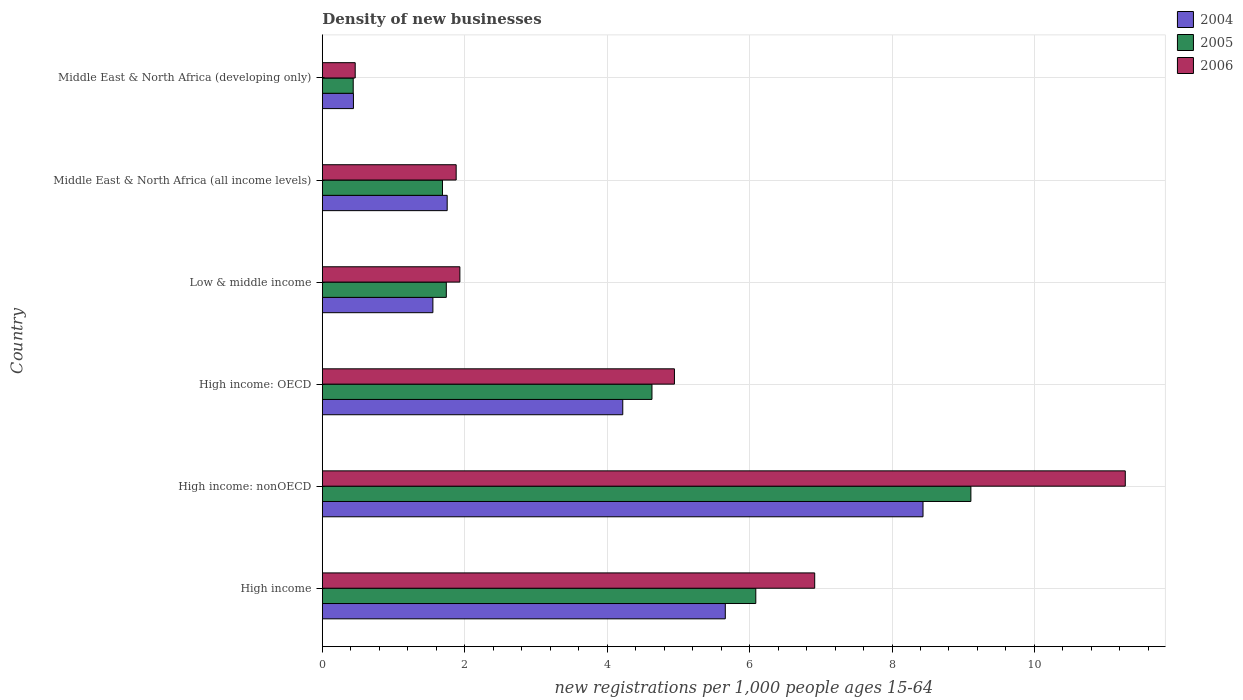How many groups of bars are there?
Provide a succinct answer. 6. Are the number of bars per tick equal to the number of legend labels?
Keep it short and to the point. Yes. What is the label of the 2nd group of bars from the top?
Your answer should be compact. Middle East & North Africa (all income levels). In how many cases, is the number of bars for a given country not equal to the number of legend labels?
Ensure brevity in your answer.  0. What is the number of new registrations in 2006 in High income: OECD?
Your answer should be very brief. 4.94. Across all countries, what is the maximum number of new registrations in 2006?
Offer a terse response. 11.28. Across all countries, what is the minimum number of new registrations in 2004?
Make the answer very short. 0.44. In which country was the number of new registrations in 2004 maximum?
Give a very brief answer. High income: nonOECD. In which country was the number of new registrations in 2006 minimum?
Your answer should be compact. Middle East & North Africa (developing only). What is the total number of new registrations in 2005 in the graph?
Offer a terse response. 23.69. What is the difference between the number of new registrations in 2005 in Low & middle income and that in Middle East & North Africa (all income levels)?
Provide a short and direct response. 0.05. What is the difference between the number of new registrations in 2004 in Middle East & North Africa (developing only) and the number of new registrations in 2005 in High income: nonOECD?
Make the answer very short. -8.67. What is the average number of new registrations in 2005 per country?
Offer a very short reply. 3.95. What is the difference between the number of new registrations in 2006 and number of new registrations in 2004 in High income: OECD?
Provide a short and direct response. 0.73. In how many countries, is the number of new registrations in 2004 greater than 8.4 ?
Give a very brief answer. 1. What is the ratio of the number of new registrations in 2006 in High income: OECD to that in Middle East & North Africa (all income levels)?
Provide a short and direct response. 2.63. Is the number of new registrations in 2005 in High income: OECD less than that in High income: nonOECD?
Your response must be concise. Yes. What is the difference between the highest and the second highest number of new registrations in 2006?
Your response must be concise. 4.36. What is the difference between the highest and the lowest number of new registrations in 2004?
Your answer should be compact. 8. In how many countries, is the number of new registrations in 2006 greater than the average number of new registrations in 2006 taken over all countries?
Offer a terse response. 3. Is the sum of the number of new registrations in 2004 in High income: OECD and Middle East & North Africa (all income levels) greater than the maximum number of new registrations in 2006 across all countries?
Provide a succinct answer. No. What does the 3rd bar from the top in Middle East & North Africa (all income levels) represents?
Make the answer very short. 2004. Is it the case that in every country, the sum of the number of new registrations in 2006 and number of new registrations in 2004 is greater than the number of new registrations in 2005?
Keep it short and to the point. Yes. Are all the bars in the graph horizontal?
Your answer should be compact. Yes. How many countries are there in the graph?
Provide a succinct answer. 6. Are the values on the major ticks of X-axis written in scientific E-notation?
Your response must be concise. No. Does the graph contain any zero values?
Your answer should be compact. No. Does the graph contain grids?
Your response must be concise. Yes. Where does the legend appear in the graph?
Make the answer very short. Top right. How are the legend labels stacked?
Your answer should be very brief. Vertical. What is the title of the graph?
Your response must be concise. Density of new businesses. Does "1962" appear as one of the legend labels in the graph?
Your answer should be compact. No. What is the label or title of the X-axis?
Ensure brevity in your answer.  New registrations per 1,0 people ages 15-64. What is the new registrations per 1,000 people ages 15-64 in 2004 in High income?
Your answer should be very brief. 5.66. What is the new registrations per 1,000 people ages 15-64 in 2005 in High income?
Give a very brief answer. 6.09. What is the new registrations per 1,000 people ages 15-64 in 2006 in High income?
Offer a very short reply. 6.91. What is the new registrations per 1,000 people ages 15-64 in 2004 in High income: nonOECD?
Provide a short and direct response. 8.44. What is the new registrations per 1,000 people ages 15-64 of 2005 in High income: nonOECD?
Make the answer very short. 9.11. What is the new registrations per 1,000 people ages 15-64 in 2006 in High income: nonOECD?
Keep it short and to the point. 11.28. What is the new registrations per 1,000 people ages 15-64 in 2004 in High income: OECD?
Offer a very short reply. 4.22. What is the new registrations per 1,000 people ages 15-64 of 2005 in High income: OECD?
Keep it short and to the point. 4.63. What is the new registrations per 1,000 people ages 15-64 in 2006 in High income: OECD?
Offer a terse response. 4.94. What is the new registrations per 1,000 people ages 15-64 in 2004 in Low & middle income?
Your answer should be very brief. 1.55. What is the new registrations per 1,000 people ages 15-64 in 2005 in Low & middle income?
Make the answer very short. 1.74. What is the new registrations per 1,000 people ages 15-64 of 2006 in Low & middle income?
Your answer should be very brief. 1.93. What is the new registrations per 1,000 people ages 15-64 in 2004 in Middle East & North Africa (all income levels)?
Give a very brief answer. 1.75. What is the new registrations per 1,000 people ages 15-64 of 2005 in Middle East & North Africa (all income levels)?
Give a very brief answer. 1.69. What is the new registrations per 1,000 people ages 15-64 in 2006 in Middle East & North Africa (all income levels)?
Offer a terse response. 1.88. What is the new registrations per 1,000 people ages 15-64 of 2004 in Middle East & North Africa (developing only)?
Give a very brief answer. 0.44. What is the new registrations per 1,000 people ages 15-64 in 2005 in Middle East & North Africa (developing only)?
Make the answer very short. 0.43. What is the new registrations per 1,000 people ages 15-64 in 2006 in Middle East & North Africa (developing only)?
Your answer should be very brief. 0.46. Across all countries, what is the maximum new registrations per 1,000 people ages 15-64 in 2004?
Offer a terse response. 8.44. Across all countries, what is the maximum new registrations per 1,000 people ages 15-64 of 2005?
Provide a succinct answer. 9.11. Across all countries, what is the maximum new registrations per 1,000 people ages 15-64 of 2006?
Your answer should be very brief. 11.28. Across all countries, what is the minimum new registrations per 1,000 people ages 15-64 of 2004?
Offer a terse response. 0.44. Across all countries, what is the minimum new registrations per 1,000 people ages 15-64 in 2005?
Ensure brevity in your answer.  0.43. Across all countries, what is the minimum new registrations per 1,000 people ages 15-64 in 2006?
Offer a terse response. 0.46. What is the total new registrations per 1,000 people ages 15-64 of 2004 in the graph?
Keep it short and to the point. 22.06. What is the total new registrations per 1,000 people ages 15-64 of 2005 in the graph?
Give a very brief answer. 23.69. What is the total new registrations per 1,000 people ages 15-64 of 2006 in the graph?
Make the answer very short. 27.41. What is the difference between the new registrations per 1,000 people ages 15-64 in 2004 in High income and that in High income: nonOECD?
Give a very brief answer. -2.78. What is the difference between the new registrations per 1,000 people ages 15-64 of 2005 in High income and that in High income: nonOECD?
Offer a very short reply. -3.02. What is the difference between the new registrations per 1,000 people ages 15-64 of 2006 in High income and that in High income: nonOECD?
Make the answer very short. -4.36. What is the difference between the new registrations per 1,000 people ages 15-64 in 2004 in High income and that in High income: OECD?
Offer a terse response. 1.44. What is the difference between the new registrations per 1,000 people ages 15-64 of 2005 in High income and that in High income: OECD?
Ensure brevity in your answer.  1.46. What is the difference between the new registrations per 1,000 people ages 15-64 of 2006 in High income and that in High income: OECD?
Provide a succinct answer. 1.97. What is the difference between the new registrations per 1,000 people ages 15-64 of 2004 in High income and that in Low & middle income?
Ensure brevity in your answer.  4.11. What is the difference between the new registrations per 1,000 people ages 15-64 of 2005 in High income and that in Low & middle income?
Your answer should be compact. 4.35. What is the difference between the new registrations per 1,000 people ages 15-64 in 2006 in High income and that in Low & middle income?
Make the answer very short. 4.98. What is the difference between the new registrations per 1,000 people ages 15-64 in 2004 in High income and that in Middle East & North Africa (all income levels)?
Ensure brevity in your answer.  3.91. What is the difference between the new registrations per 1,000 people ages 15-64 of 2005 in High income and that in Middle East & North Africa (all income levels)?
Offer a terse response. 4.4. What is the difference between the new registrations per 1,000 people ages 15-64 of 2006 in High income and that in Middle East & North Africa (all income levels)?
Keep it short and to the point. 5.04. What is the difference between the new registrations per 1,000 people ages 15-64 in 2004 in High income and that in Middle East & North Africa (developing only)?
Your answer should be compact. 5.22. What is the difference between the new registrations per 1,000 people ages 15-64 of 2005 in High income and that in Middle East & North Africa (developing only)?
Your answer should be very brief. 5.65. What is the difference between the new registrations per 1,000 people ages 15-64 in 2006 in High income and that in Middle East & North Africa (developing only)?
Offer a terse response. 6.45. What is the difference between the new registrations per 1,000 people ages 15-64 in 2004 in High income: nonOECD and that in High income: OECD?
Your answer should be very brief. 4.22. What is the difference between the new registrations per 1,000 people ages 15-64 in 2005 in High income: nonOECD and that in High income: OECD?
Provide a succinct answer. 4.48. What is the difference between the new registrations per 1,000 people ages 15-64 in 2006 in High income: nonOECD and that in High income: OECD?
Your response must be concise. 6.33. What is the difference between the new registrations per 1,000 people ages 15-64 of 2004 in High income: nonOECD and that in Low & middle income?
Ensure brevity in your answer.  6.88. What is the difference between the new registrations per 1,000 people ages 15-64 in 2005 in High income: nonOECD and that in Low & middle income?
Ensure brevity in your answer.  7.37. What is the difference between the new registrations per 1,000 people ages 15-64 in 2006 in High income: nonOECD and that in Low & middle income?
Provide a short and direct response. 9.34. What is the difference between the new registrations per 1,000 people ages 15-64 in 2004 in High income: nonOECD and that in Middle East & North Africa (all income levels)?
Offer a terse response. 6.68. What is the difference between the new registrations per 1,000 people ages 15-64 in 2005 in High income: nonOECD and that in Middle East & North Africa (all income levels)?
Your answer should be very brief. 7.42. What is the difference between the new registrations per 1,000 people ages 15-64 in 2006 in High income: nonOECD and that in Middle East & North Africa (all income levels)?
Provide a short and direct response. 9.4. What is the difference between the new registrations per 1,000 people ages 15-64 of 2004 in High income: nonOECD and that in Middle East & North Africa (developing only)?
Offer a very short reply. 8. What is the difference between the new registrations per 1,000 people ages 15-64 in 2005 in High income: nonOECD and that in Middle East & North Africa (developing only)?
Offer a terse response. 8.67. What is the difference between the new registrations per 1,000 people ages 15-64 in 2006 in High income: nonOECD and that in Middle East & North Africa (developing only)?
Offer a very short reply. 10.81. What is the difference between the new registrations per 1,000 people ages 15-64 of 2004 in High income: OECD and that in Low & middle income?
Offer a terse response. 2.67. What is the difference between the new registrations per 1,000 people ages 15-64 in 2005 in High income: OECD and that in Low & middle income?
Offer a very short reply. 2.89. What is the difference between the new registrations per 1,000 people ages 15-64 in 2006 in High income: OECD and that in Low & middle income?
Your answer should be very brief. 3.01. What is the difference between the new registrations per 1,000 people ages 15-64 of 2004 in High income: OECD and that in Middle East & North Africa (all income levels)?
Your answer should be very brief. 2.47. What is the difference between the new registrations per 1,000 people ages 15-64 in 2005 in High income: OECD and that in Middle East & North Africa (all income levels)?
Keep it short and to the point. 2.94. What is the difference between the new registrations per 1,000 people ages 15-64 in 2006 in High income: OECD and that in Middle East & North Africa (all income levels)?
Offer a very short reply. 3.07. What is the difference between the new registrations per 1,000 people ages 15-64 of 2004 in High income: OECD and that in Middle East & North Africa (developing only)?
Your answer should be very brief. 3.78. What is the difference between the new registrations per 1,000 people ages 15-64 in 2005 in High income: OECD and that in Middle East & North Africa (developing only)?
Offer a very short reply. 4.2. What is the difference between the new registrations per 1,000 people ages 15-64 in 2006 in High income: OECD and that in Middle East & North Africa (developing only)?
Provide a succinct answer. 4.48. What is the difference between the new registrations per 1,000 people ages 15-64 of 2004 in Low & middle income and that in Middle East & North Africa (all income levels)?
Offer a terse response. -0.2. What is the difference between the new registrations per 1,000 people ages 15-64 of 2005 in Low & middle income and that in Middle East & North Africa (all income levels)?
Your answer should be compact. 0.05. What is the difference between the new registrations per 1,000 people ages 15-64 of 2006 in Low & middle income and that in Middle East & North Africa (all income levels)?
Your answer should be compact. 0.05. What is the difference between the new registrations per 1,000 people ages 15-64 in 2004 in Low & middle income and that in Middle East & North Africa (developing only)?
Your answer should be compact. 1.12. What is the difference between the new registrations per 1,000 people ages 15-64 of 2005 in Low & middle income and that in Middle East & North Africa (developing only)?
Ensure brevity in your answer.  1.31. What is the difference between the new registrations per 1,000 people ages 15-64 of 2006 in Low & middle income and that in Middle East & North Africa (developing only)?
Your answer should be compact. 1.47. What is the difference between the new registrations per 1,000 people ages 15-64 of 2004 in Middle East & North Africa (all income levels) and that in Middle East & North Africa (developing only)?
Ensure brevity in your answer.  1.32. What is the difference between the new registrations per 1,000 people ages 15-64 of 2005 in Middle East & North Africa (all income levels) and that in Middle East & North Africa (developing only)?
Provide a succinct answer. 1.25. What is the difference between the new registrations per 1,000 people ages 15-64 of 2006 in Middle East & North Africa (all income levels) and that in Middle East & North Africa (developing only)?
Offer a terse response. 1.42. What is the difference between the new registrations per 1,000 people ages 15-64 in 2004 in High income and the new registrations per 1,000 people ages 15-64 in 2005 in High income: nonOECD?
Your answer should be very brief. -3.45. What is the difference between the new registrations per 1,000 people ages 15-64 in 2004 in High income and the new registrations per 1,000 people ages 15-64 in 2006 in High income: nonOECD?
Offer a very short reply. -5.62. What is the difference between the new registrations per 1,000 people ages 15-64 in 2005 in High income and the new registrations per 1,000 people ages 15-64 in 2006 in High income: nonOECD?
Provide a short and direct response. -5.19. What is the difference between the new registrations per 1,000 people ages 15-64 of 2004 in High income and the new registrations per 1,000 people ages 15-64 of 2005 in High income: OECD?
Your answer should be very brief. 1.03. What is the difference between the new registrations per 1,000 people ages 15-64 of 2004 in High income and the new registrations per 1,000 people ages 15-64 of 2006 in High income: OECD?
Your answer should be very brief. 0.71. What is the difference between the new registrations per 1,000 people ages 15-64 in 2005 in High income and the new registrations per 1,000 people ages 15-64 in 2006 in High income: OECD?
Offer a very short reply. 1.14. What is the difference between the new registrations per 1,000 people ages 15-64 of 2004 in High income and the new registrations per 1,000 people ages 15-64 of 2005 in Low & middle income?
Your answer should be compact. 3.92. What is the difference between the new registrations per 1,000 people ages 15-64 of 2004 in High income and the new registrations per 1,000 people ages 15-64 of 2006 in Low & middle income?
Provide a short and direct response. 3.73. What is the difference between the new registrations per 1,000 people ages 15-64 of 2005 in High income and the new registrations per 1,000 people ages 15-64 of 2006 in Low & middle income?
Provide a succinct answer. 4.16. What is the difference between the new registrations per 1,000 people ages 15-64 of 2004 in High income and the new registrations per 1,000 people ages 15-64 of 2005 in Middle East & North Africa (all income levels)?
Offer a very short reply. 3.97. What is the difference between the new registrations per 1,000 people ages 15-64 of 2004 in High income and the new registrations per 1,000 people ages 15-64 of 2006 in Middle East & North Africa (all income levels)?
Offer a very short reply. 3.78. What is the difference between the new registrations per 1,000 people ages 15-64 in 2005 in High income and the new registrations per 1,000 people ages 15-64 in 2006 in Middle East & North Africa (all income levels)?
Offer a very short reply. 4.21. What is the difference between the new registrations per 1,000 people ages 15-64 of 2004 in High income and the new registrations per 1,000 people ages 15-64 of 2005 in Middle East & North Africa (developing only)?
Provide a short and direct response. 5.22. What is the difference between the new registrations per 1,000 people ages 15-64 in 2004 in High income and the new registrations per 1,000 people ages 15-64 in 2006 in Middle East & North Africa (developing only)?
Make the answer very short. 5.2. What is the difference between the new registrations per 1,000 people ages 15-64 of 2005 in High income and the new registrations per 1,000 people ages 15-64 of 2006 in Middle East & North Africa (developing only)?
Offer a terse response. 5.63. What is the difference between the new registrations per 1,000 people ages 15-64 in 2004 in High income: nonOECD and the new registrations per 1,000 people ages 15-64 in 2005 in High income: OECD?
Your answer should be compact. 3.81. What is the difference between the new registrations per 1,000 people ages 15-64 of 2004 in High income: nonOECD and the new registrations per 1,000 people ages 15-64 of 2006 in High income: OECD?
Ensure brevity in your answer.  3.49. What is the difference between the new registrations per 1,000 people ages 15-64 in 2005 in High income: nonOECD and the new registrations per 1,000 people ages 15-64 in 2006 in High income: OECD?
Your answer should be very brief. 4.16. What is the difference between the new registrations per 1,000 people ages 15-64 in 2004 in High income: nonOECD and the new registrations per 1,000 people ages 15-64 in 2005 in Low & middle income?
Your answer should be very brief. 6.69. What is the difference between the new registrations per 1,000 people ages 15-64 in 2004 in High income: nonOECD and the new registrations per 1,000 people ages 15-64 in 2006 in Low & middle income?
Offer a very short reply. 6.5. What is the difference between the new registrations per 1,000 people ages 15-64 in 2005 in High income: nonOECD and the new registrations per 1,000 people ages 15-64 in 2006 in Low & middle income?
Make the answer very short. 7.18. What is the difference between the new registrations per 1,000 people ages 15-64 of 2004 in High income: nonOECD and the new registrations per 1,000 people ages 15-64 of 2005 in Middle East & North Africa (all income levels)?
Ensure brevity in your answer.  6.75. What is the difference between the new registrations per 1,000 people ages 15-64 in 2004 in High income: nonOECD and the new registrations per 1,000 people ages 15-64 in 2006 in Middle East & North Africa (all income levels)?
Your answer should be compact. 6.56. What is the difference between the new registrations per 1,000 people ages 15-64 of 2005 in High income: nonOECD and the new registrations per 1,000 people ages 15-64 of 2006 in Middle East & North Africa (all income levels)?
Your answer should be very brief. 7.23. What is the difference between the new registrations per 1,000 people ages 15-64 in 2004 in High income: nonOECD and the new registrations per 1,000 people ages 15-64 in 2005 in Middle East & North Africa (developing only)?
Offer a very short reply. 8. What is the difference between the new registrations per 1,000 people ages 15-64 of 2004 in High income: nonOECD and the new registrations per 1,000 people ages 15-64 of 2006 in Middle East & North Africa (developing only)?
Ensure brevity in your answer.  7.97. What is the difference between the new registrations per 1,000 people ages 15-64 of 2005 in High income: nonOECD and the new registrations per 1,000 people ages 15-64 of 2006 in Middle East & North Africa (developing only)?
Give a very brief answer. 8.65. What is the difference between the new registrations per 1,000 people ages 15-64 in 2004 in High income: OECD and the new registrations per 1,000 people ages 15-64 in 2005 in Low & middle income?
Offer a very short reply. 2.48. What is the difference between the new registrations per 1,000 people ages 15-64 of 2004 in High income: OECD and the new registrations per 1,000 people ages 15-64 of 2006 in Low & middle income?
Offer a terse response. 2.29. What is the difference between the new registrations per 1,000 people ages 15-64 in 2005 in High income: OECD and the new registrations per 1,000 people ages 15-64 in 2006 in Low & middle income?
Ensure brevity in your answer.  2.7. What is the difference between the new registrations per 1,000 people ages 15-64 of 2004 in High income: OECD and the new registrations per 1,000 people ages 15-64 of 2005 in Middle East & North Africa (all income levels)?
Your answer should be compact. 2.53. What is the difference between the new registrations per 1,000 people ages 15-64 of 2004 in High income: OECD and the new registrations per 1,000 people ages 15-64 of 2006 in Middle East & North Africa (all income levels)?
Ensure brevity in your answer.  2.34. What is the difference between the new registrations per 1,000 people ages 15-64 of 2005 in High income: OECD and the new registrations per 1,000 people ages 15-64 of 2006 in Middle East & North Africa (all income levels)?
Your response must be concise. 2.75. What is the difference between the new registrations per 1,000 people ages 15-64 in 2004 in High income: OECD and the new registrations per 1,000 people ages 15-64 in 2005 in Middle East & North Africa (developing only)?
Ensure brevity in your answer.  3.79. What is the difference between the new registrations per 1,000 people ages 15-64 of 2004 in High income: OECD and the new registrations per 1,000 people ages 15-64 of 2006 in Middle East & North Africa (developing only)?
Your response must be concise. 3.76. What is the difference between the new registrations per 1,000 people ages 15-64 in 2005 in High income: OECD and the new registrations per 1,000 people ages 15-64 in 2006 in Middle East & North Africa (developing only)?
Offer a terse response. 4.17. What is the difference between the new registrations per 1,000 people ages 15-64 in 2004 in Low & middle income and the new registrations per 1,000 people ages 15-64 in 2005 in Middle East & North Africa (all income levels)?
Give a very brief answer. -0.13. What is the difference between the new registrations per 1,000 people ages 15-64 in 2004 in Low & middle income and the new registrations per 1,000 people ages 15-64 in 2006 in Middle East & North Africa (all income levels)?
Ensure brevity in your answer.  -0.33. What is the difference between the new registrations per 1,000 people ages 15-64 of 2005 in Low & middle income and the new registrations per 1,000 people ages 15-64 of 2006 in Middle East & North Africa (all income levels)?
Make the answer very short. -0.14. What is the difference between the new registrations per 1,000 people ages 15-64 of 2004 in Low & middle income and the new registrations per 1,000 people ages 15-64 of 2005 in Middle East & North Africa (developing only)?
Give a very brief answer. 1.12. What is the difference between the new registrations per 1,000 people ages 15-64 of 2005 in Low & middle income and the new registrations per 1,000 people ages 15-64 of 2006 in Middle East & North Africa (developing only)?
Offer a terse response. 1.28. What is the difference between the new registrations per 1,000 people ages 15-64 in 2004 in Middle East & North Africa (all income levels) and the new registrations per 1,000 people ages 15-64 in 2005 in Middle East & North Africa (developing only)?
Make the answer very short. 1.32. What is the difference between the new registrations per 1,000 people ages 15-64 of 2004 in Middle East & North Africa (all income levels) and the new registrations per 1,000 people ages 15-64 of 2006 in Middle East & North Africa (developing only)?
Offer a terse response. 1.29. What is the difference between the new registrations per 1,000 people ages 15-64 of 2005 in Middle East & North Africa (all income levels) and the new registrations per 1,000 people ages 15-64 of 2006 in Middle East & North Africa (developing only)?
Offer a terse response. 1.23. What is the average new registrations per 1,000 people ages 15-64 of 2004 per country?
Give a very brief answer. 3.68. What is the average new registrations per 1,000 people ages 15-64 of 2005 per country?
Keep it short and to the point. 3.95. What is the average new registrations per 1,000 people ages 15-64 of 2006 per country?
Provide a short and direct response. 4.57. What is the difference between the new registrations per 1,000 people ages 15-64 in 2004 and new registrations per 1,000 people ages 15-64 in 2005 in High income?
Ensure brevity in your answer.  -0.43. What is the difference between the new registrations per 1,000 people ages 15-64 of 2004 and new registrations per 1,000 people ages 15-64 of 2006 in High income?
Keep it short and to the point. -1.26. What is the difference between the new registrations per 1,000 people ages 15-64 in 2005 and new registrations per 1,000 people ages 15-64 in 2006 in High income?
Ensure brevity in your answer.  -0.83. What is the difference between the new registrations per 1,000 people ages 15-64 in 2004 and new registrations per 1,000 people ages 15-64 in 2005 in High income: nonOECD?
Offer a very short reply. -0.67. What is the difference between the new registrations per 1,000 people ages 15-64 of 2004 and new registrations per 1,000 people ages 15-64 of 2006 in High income: nonOECD?
Your answer should be very brief. -2.84. What is the difference between the new registrations per 1,000 people ages 15-64 in 2005 and new registrations per 1,000 people ages 15-64 in 2006 in High income: nonOECD?
Make the answer very short. -2.17. What is the difference between the new registrations per 1,000 people ages 15-64 in 2004 and new registrations per 1,000 people ages 15-64 in 2005 in High income: OECD?
Offer a terse response. -0.41. What is the difference between the new registrations per 1,000 people ages 15-64 of 2004 and new registrations per 1,000 people ages 15-64 of 2006 in High income: OECD?
Your answer should be very brief. -0.73. What is the difference between the new registrations per 1,000 people ages 15-64 in 2005 and new registrations per 1,000 people ages 15-64 in 2006 in High income: OECD?
Your answer should be very brief. -0.32. What is the difference between the new registrations per 1,000 people ages 15-64 in 2004 and new registrations per 1,000 people ages 15-64 in 2005 in Low & middle income?
Offer a terse response. -0.19. What is the difference between the new registrations per 1,000 people ages 15-64 of 2004 and new registrations per 1,000 people ages 15-64 of 2006 in Low & middle income?
Give a very brief answer. -0.38. What is the difference between the new registrations per 1,000 people ages 15-64 of 2005 and new registrations per 1,000 people ages 15-64 of 2006 in Low & middle income?
Make the answer very short. -0.19. What is the difference between the new registrations per 1,000 people ages 15-64 of 2004 and new registrations per 1,000 people ages 15-64 of 2005 in Middle East & North Africa (all income levels)?
Your answer should be very brief. 0.07. What is the difference between the new registrations per 1,000 people ages 15-64 of 2004 and new registrations per 1,000 people ages 15-64 of 2006 in Middle East & North Africa (all income levels)?
Offer a terse response. -0.13. What is the difference between the new registrations per 1,000 people ages 15-64 in 2005 and new registrations per 1,000 people ages 15-64 in 2006 in Middle East & North Africa (all income levels)?
Give a very brief answer. -0.19. What is the difference between the new registrations per 1,000 people ages 15-64 of 2004 and new registrations per 1,000 people ages 15-64 of 2005 in Middle East & North Africa (developing only)?
Offer a very short reply. 0. What is the difference between the new registrations per 1,000 people ages 15-64 of 2004 and new registrations per 1,000 people ages 15-64 of 2006 in Middle East & North Africa (developing only)?
Make the answer very short. -0.02. What is the difference between the new registrations per 1,000 people ages 15-64 of 2005 and new registrations per 1,000 people ages 15-64 of 2006 in Middle East & North Africa (developing only)?
Make the answer very short. -0.03. What is the ratio of the new registrations per 1,000 people ages 15-64 in 2004 in High income to that in High income: nonOECD?
Offer a terse response. 0.67. What is the ratio of the new registrations per 1,000 people ages 15-64 of 2005 in High income to that in High income: nonOECD?
Give a very brief answer. 0.67. What is the ratio of the new registrations per 1,000 people ages 15-64 in 2006 in High income to that in High income: nonOECD?
Your answer should be very brief. 0.61. What is the ratio of the new registrations per 1,000 people ages 15-64 of 2004 in High income to that in High income: OECD?
Provide a succinct answer. 1.34. What is the ratio of the new registrations per 1,000 people ages 15-64 of 2005 in High income to that in High income: OECD?
Offer a terse response. 1.31. What is the ratio of the new registrations per 1,000 people ages 15-64 in 2006 in High income to that in High income: OECD?
Offer a very short reply. 1.4. What is the ratio of the new registrations per 1,000 people ages 15-64 of 2004 in High income to that in Low & middle income?
Offer a very short reply. 3.64. What is the ratio of the new registrations per 1,000 people ages 15-64 of 2005 in High income to that in Low & middle income?
Your response must be concise. 3.5. What is the ratio of the new registrations per 1,000 people ages 15-64 of 2006 in High income to that in Low & middle income?
Offer a terse response. 3.58. What is the ratio of the new registrations per 1,000 people ages 15-64 in 2004 in High income to that in Middle East & North Africa (all income levels)?
Your answer should be very brief. 3.23. What is the ratio of the new registrations per 1,000 people ages 15-64 of 2005 in High income to that in Middle East & North Africa (all income levels)?
Make the answer very short. 3.61. What is the ratio of the new registrations per 1,000 people ages 15-64 of 2006 in High income to that in Middle East & North Africa (all income levels)?
Make the answer very short. 3.68. What is the ratio of the new registrations per 1,000 people ages 15-64 in 2004 in High income to that in Middle East & North Africa (developing only)?
Provide a short and direct response. 12.96. What is the ratio of the new registrations per 1,000 people ages 15-64 in 2005 in High income to that in Middle East & North Africa (developing only)?
Your answer should be very brief. 14.03. What is the ratio of the new registrations per 1,000 people ages 15-64 of 2006 in High income to that in Middle East & North Africa (developing only)?
Offer a terse response. 14.98. What is the ratio of the new registrations per 1,000 people ages 15-64 in 2004 in High income: nonOECD to that in High income: OECD?
Your answer should be very brief. 2. What is the ratio of the new registrations per 1,000 people ages 15-64 in 2005 in High income: nonOECD to that in High income: OECD?
Make the answer very short. 1.97. What is the ratio of the new registrations per 1,000 people ages 15-64 of 2006 in High income: nonOECD to that in High income: OECD?
Offer a terse response. 2.28. What is the ratio of the new registrations per 1,000 people ages 15-64 in 2004 in High income: nonOECD to that in Low & middle income?
Ensure brevity in your answer.  5.43. What is the ratio of the new registrations per 1,000 people ages 15-64 of 2005 in High income: nonOECD to that in Low & middle income?
Your response must be concise. 5.23. What is the ratio of the new registrations per 1,000 people ages 15-64 in 2006 in High income: nonOECD to that in Low & middle income?
Give a very brief answer. 5.84. What is the ratio of the new registrations per 1,000 people ages 15-64 in 2004 in High income: nonOECD to that in Middle East & North Africa (all income levels)?
Your answer should be very brief. 4.81. What is the ratio of the new registrations per 1,000 people ages 15-64 of 2005 in High income: nonOECD to that in Middle East & North Africa (all income levels)?
Keep it short and to the point. 5.4. What is the ratio of the new registrations per 1,000 people ages 15-64 in 2006 in High income: nonOECD to that in Middle East & North Africa (all income levels)?
Keep it short and to the point. 6. What is the ratio of the new registrations per 1,000 people ages 15-64 in 2004 in High income: nonOECD to that in Middle East & North Africa (developing only)?
Offer a very short reply. 19.31. What is the ratio of the new registrations per 1,000 people ages 15-64 of 2005 in High income: nonOECD to that in Middle East & North Africa (developing only)?
Your response must be concise. 20.99. What is the ratio of the new registrations per 1,000 people ages 15-64 of 2006 in High income: nonOECD to that in Middle East & North Africa (developing only)?
Your answer should be very brief. 24.42. What is the ratio of the new registrations per 1,000 people ages 15-64 of 2004 in High income: OECD to that in Low & middle income?
Offer a terse response. 2.72. What is the ratio of the new registrations per 1,000 people ages 15-64 of 2005 in High income: OECD to that in Low & middle income?
Provide a short and direct response. 2.66. What is the ratio of the new registrations per 1,000 people ages 15-64 in 2006 in High income: OECD to that in Low & middle income?
Offer a terse response. 2.56. What is the ratio of the new registrations per 1,000 people ages 15-64 of 2004 in High income: OECD to that in Middle East & North Africa (all income levels)?
Ensure brevity in your answer.  2.41. What is the ratio of the new registrations per 1,000 people ages 15-64 of 2005 in High income: OECD to that in Middle East & North Africa (all income levels)?
Keep it short and to the point. 2.74. What is the ratio of the new registrations per 1,000 people ages 15-64 in 2006 in High income: OECD to that in Middle East & North Africa (all income levels)?
Offer a terse response. 2.63. What is the ratio of the new registrations per 1,000 people ages 15-64 in 2004 in High income: OECD to that in Middle East & North Africa (developing only)?
Your answer should be very brief. 9.66. What is the ratio of the new registrations per 1,000 people ages 15-64 in 2005 in High income: OECD to that in Middle East & North Africa (developing only)?
Provide a succinct answer. 10.67. What is the ratio of the new registrations per 1,000 people ages 15-64 of 2006 in High income: OECD to that in Middle East & North Africa (developing only)?
Provide a succinct answer. 10.71. What is the ratio of the new registrations per 1,000 people ages 15-64 in 2004 in Low & middle income to that in Middle East & North Africa (all income levels)?
Give a very brief answer. 0.89. What is the ratio of the new registrations per 1,000 people ages 15-64 of 2005 in Low & middle income to that in Middle East & North Africa (all income levels)?
Ensure brevity in your answer.  1.03. What is the ratio of the new registrations per 1,000 people ages 15-64 of 2006 in Low & middle income to that in Middle East & North Africa (all income levels)?
Make the answer very short. 1.03. What is the ratio of the new registrations per 1,000 people ages 15-64 in 2004 in Low & middle income to that in Middle East & North Africa (developing only)?
Give a very brief answer. 3.55. What is the ratio of the new registrations per 1,000 people ages 15-64 of 2005 in Low & middle income to that in Middle East & North Africa (developing only)?
Your answer should be compact. 4.01. What is the ratio of the new registrations per 1,000 people ages 15-64 of 2006 in Low & middle income to that in Middle East & North Africa (developing only)?
Provide a succinct answer. 4.18. What is the ratio of the new registrations per 1,000 people ages 15-64 in 2004 in Middle East & North Africa (all income levels) to that in Middle East & North Africa (developing only)?
Provide a succinct answer. 4.01. What is the ratio of the new registrations per 1,000 people ages 15-64 in 2005 in Middle East & North Africa (all income levels) to that in Middle East & North Africa (developing only)?
Provide a short and direct response. 3.89. What is the ratio of the new registrations per 1,000 people ages 15-64 of 2006 in Middle East & North Africa (all income levels) to that in Middle East & North Africa (developing only)?
Offer a terse response. 4.07. What is the difference between the highest and the second highest new registrations per 1,000 people ages 15-64 of 2004?
Provide a succinct answer. 2.78. What is the difference between the highest and the second highest new registrations per 1,000 people ages 15-64 in 2005?
Offer a terse response. 3.02. What is the difference between the highest and the second highest new registrations per 1,000 people ages 15-64 of 2006?
Your answer should be very brief. 4.36. What is the difference between the highest and the lowest new registrations per 1,000 people ages 15-64 of 2004?
Give a very brief answer. 8. What is the difference between the highest and the lowest new registrations per 1,000 people ages 15-64 of 2005?
Offer a very short reply. 8.67. What is the difference between the highest and the lowest new registrations per 1,000 people ages 15-64 in 2006?
Provide a succinct answer. 10.81. 